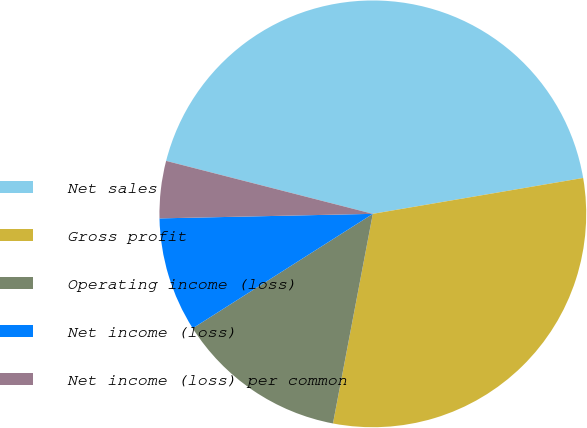Convert chart. <chart><loc_0><loc_0><loc_500><loc_500><pie_chart><fcel>Net sales<fcel>Gross profit<fcel>Operating income (loss)<fcel>Net income (loss)<fcel>Net income (loss) per common<nl><fcel>43.32%<fcel>30.68%<fcel>13.0%<fcel>8.67%<fcel>4.33%<nl></chart> 